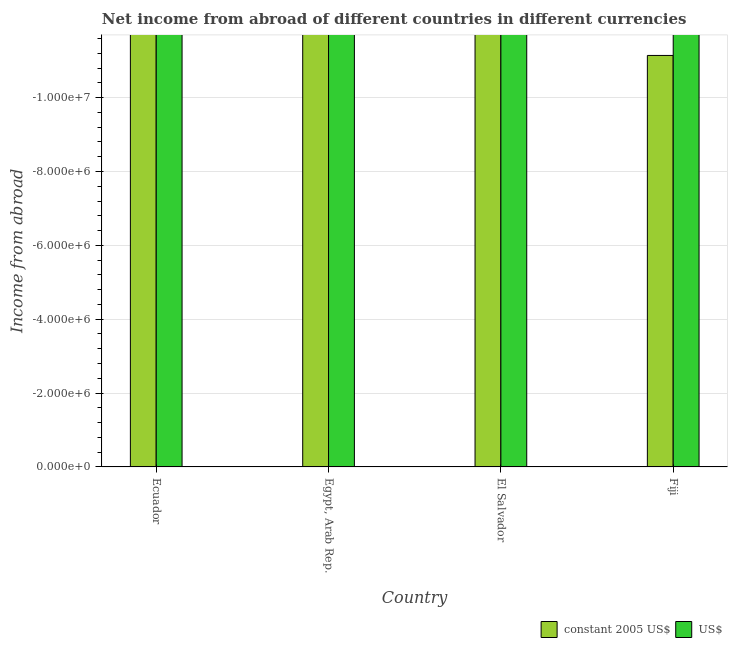How many different coloured bars are there?
Ensure brevity in your answer.  0. Are the number of bars on each tick of the X-axis equal?
Provide a short and direct response. Yes. How many bars are there on the 4th tick from the left?
Keep it short and to the point. 0. How many bars are there on the 3rd tick from the right?
Your answer should be compact. 0. What is the label of the 2nd group of bars from the left?
Ensure brevity in your answer.  Egypt, Arab Rep. In how many cases, is the number of bars for a given country not equal to the number of legend labels?
Offer a terse response. 4. What is the difference between the income from abroad in us$ in Ecuador and the income from abroad in constant 2005 us$ in Egypt, Arab Rep.?
Provide a short and direct response. 0. In how many countries, is the income from abroad in constant 2005 us$ greater than the average income from abroad in constant 2005 us$ taken over all countries?
Your answer should be very brief. 0. How many countries are there in the graph?
Your answer should be compact. 4. What is the difference between two consecutive major ticks on the Y-axis?
Provide a succinct answer. 2.00e+06. Does the graph contain grids?
Your answer should be very brief. Yes. Where does the legend appear in the graph?
Ensure brevity in your answer.  Bottom right. How are the legend labels stacked?
Your answer should be compact. Horizontal. What is the title of the graph?
Make the answer very short. Net income from abroad of different countries in different currencies. What is the label or title of the Y-axis?
Provide a succinct answer. Income from abroad. What is the Income from abroad in constant 2005 US$ in Egypt, Arab Rep.?
Your answer should be very brief. 0. What is the Income from abroad in US$ in Egypt, Arab Rep.?
Your answer should be very brief. 0. What is the Income from abroad of constant 2005 US$ in El Salvador?
Your answer should be very brief. 0. What is the Income from abroad in US$ in El Salvador?
Offer a terse response. 0. What is the Income from abroad in US$ in Fiji?
Give a very brief answer. 0. What is the total Income from abroad of constant 2005 US$ in the graph?
Your answer should be compact. 0. What is the average Income from abroad in constant 2005 US$ per country?
Offer a terse response. 0. What is the average Income from abroad of US$ per country?
Provide a succinct answer. 0. 